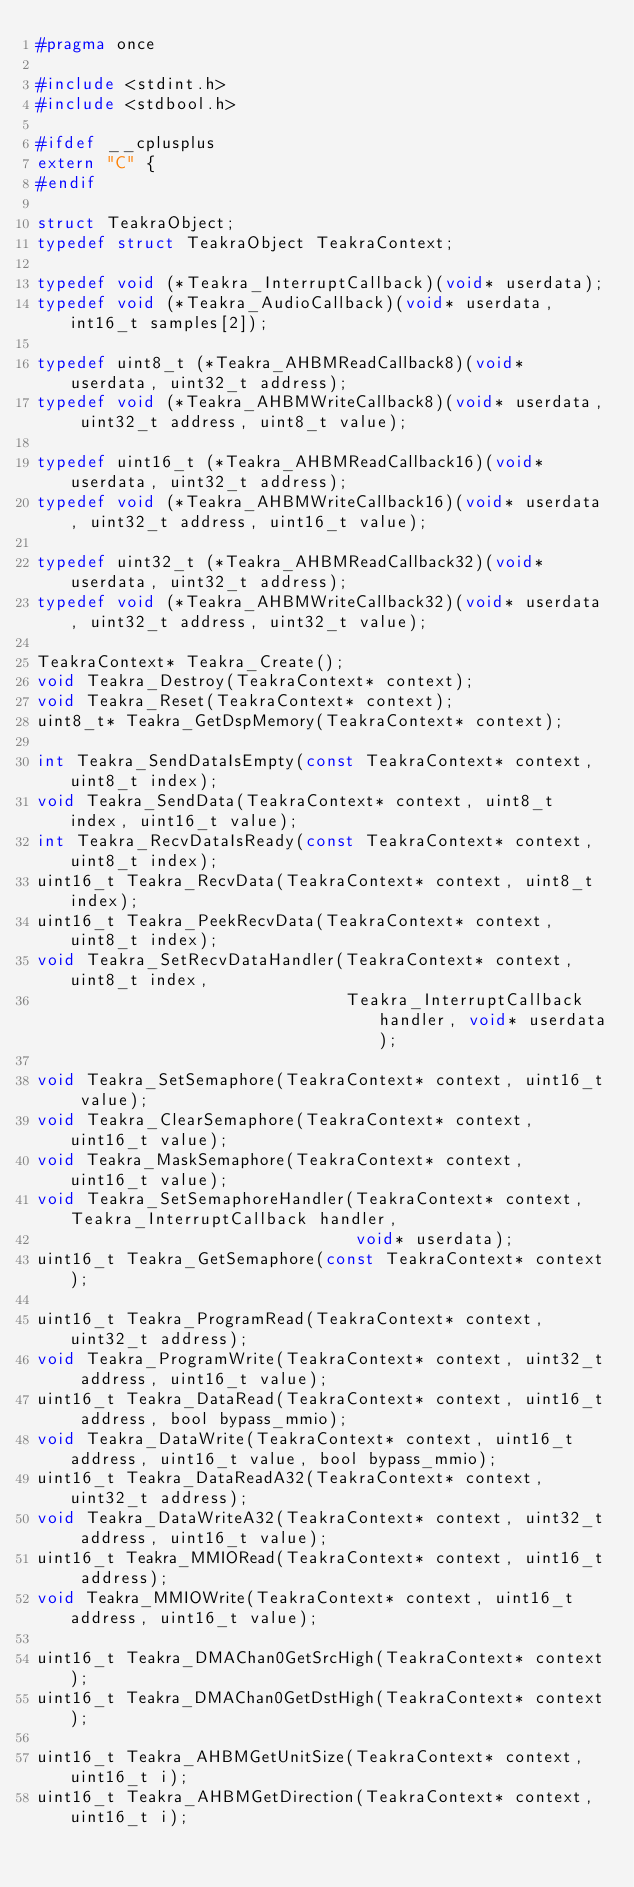<code> <loc_0><loc_0><loc_500><loc_500><_C_>#pragma once

#include <stdint.h>
#include <stdbool.h>

#ifdef __cplusplus
extern "C" {
#endif

struct TeakraObject;
typedef struct TeakraObject TeakraContext;

typedef void (*Teakra_InterruptCallback)(void* userdata);
typedef void (*Teakra_AudioCallback)(void* userdata, int16_t samples[2]);

typedef uint8_t (*Teakra_AHBMReadCallback8)(void* userdata, uint32_t address);
typedef void (*Teakra_AHBMWriteCallback8)(void* userdata, uint32_t address, uint8_t value);

typedef uint16_t (*Teakra_AHBMReadCallback16)(void* userdata, uint32_t address);
typedef void (*Teakra_AHBMWriteCallback16)(void* userdata, uint32_t address, uint16_t value);

typedef uint32_t (*Teakra_AHBMReadCallback32)(void* userdata, uint32_t address);
typedef void (*Teakra_AHBMWriteCallback32)(void* userdata, uint32_t address, uint32_t value);

TeakraContext* Teakra_Create();
void Teakra_Destroy(TeakraContext* context);
void Teakra_Reset(TeakraContext* context);
uint8_t* Teakra_GetDspMemory(TeakraContext* context);

int Teakra_SendDataIsEmpty(const TeakraContext* context, uint8_t index);
void Teakra_SendData(TeakraContext* context, uint8_t index, uint16_t value);
int Teakra_RecvDataIsReady(const TeakraContext* context, uint8_t index);
uint16_t Teakra_RecvData(TeakraContext* context, uint8_t index);
uint16_t Teakra_PeekRecvData(TeakraContext* context, uint8_t index);
void Teakra_SetRecvDataHandler(TeakraContext* context, uint8_t index,
                               Teakra_InterruptCallback handler, void* userdata);

void Teakra_SetSemaphore(TeakraContext* context, uint16_t value);
void Teakra_ClearSemaphore(TeakraContext* context, uint16_t value);
void Teakra_MaskSemaphore(TeakraContext* context, uint16_t value);
void Teakra_SetSemaphoreHandler(TeakraContext* context, Teakra_InterruptCallback handler,
                                void* userdata);
uint16_t Teakra_GetSemaphore(const TeakraContext* context);

uint16_t Teakra_ProgramRead(TeakraContext* context, uint32_t address);
void Teakra_ProgramWrite(TeakraContext* context, uint32_t address, uint16_t value);
uint16_t Teakra_DataRead(TeakraContext* context, uint16_t address, bool bypass_mmio);
void Teakra_DataWrite(TeakraContext* context, uint16_t address, uint16_t value, bool bypass_mmio);
uint16_t Teakra_DataReadA32(TeakraContext* context, uint32_t address);
void Teakra_DataWriteA32(TeakraContext* context, uint32_t address, uint16_t value);
uint16_t Teakra_MMIORead(TeakraContext* context, uint16_t address);
void Teakra_MMIOWrite(TeakraContext* context, uint16_t address, uint16_t value);

uint16_t Teakra_DMAChan0GetSrcHigh(TeakraContext* context);
uint16_t Teakra_DMAChan0GetDstHigh(TeakraContext* context);

uint16_t Teakra_AHBMGetUnitSize(TeakraContext* context, uint16_t i);
uint16_t Teakra_AHBMGetDirection(TeakraContext* context, uint16_t i);</code> 